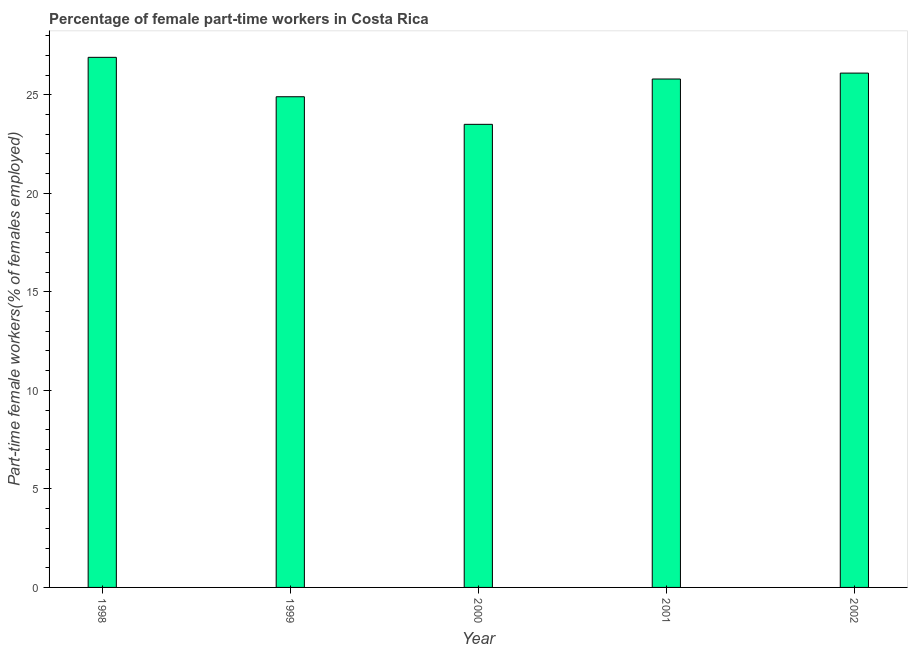Does the graph contain grids?
Give a very brief answer. No. What is the title of the graph?
Your answer should be very brief. Percentage of female part-time workers in Costa Rica. What is the label or title of the Y-axis?
Provide a short and direct response. Part-time female workers(% of females employed). Across all years, what is the maximum percentage of part-time female workers?
Your answer should be compact. 26.9. Across all years, what is the minimum percentage of part-time female workers?
Keep it short and to the point. 23.5. In which year was the percentage of part-time female workers minimum?
Offer a very short reply. 2000. What is the sum of the percentage of part-time female workers?
Keep it short and to the point. 127.2. What is the difference between the percentage of part-time female workers in 2000 and 2001?
Your answer should be very brief. -2.3. What is the average percentage of part-time female workers per year?
Make the answer very short. 25.44. What is the median percentage of part-time female workers?
Provide a succinct answer. 25.8. In how many years, is the percentage of part-time female workers greater than 10 %?
Provide a succinct answer. 5. What is the difference between the highest and the second highest percentage of part-time female workers?
Provide a short and direct response. 0.8. Is the sum of the percentage of part-time female workers in 2001 and 2002 greater than the maximum percentage of part-time female workers across all years?
Give a very brief answer. Yes. How many years are there in the graph?
Provide a short and direct response. 5. What is the difference between two consecutive major ticks on the Y-axis?
Provide a short and direct response. 5. Are the values on the major ticks of Y-axis written in scientific E-notation?
Keep it short and to the point. No. What is the Part-time female workers(% of females employed) of 1998?
Give a very brief answer. 26.9. What is the Part-time female workers(% of females employed) of 1999?
Make the answer very short. 24.9. What is the Part-time female workers(% of females employed) of 2001?
Offer a very short reply. 25.8. What is the Part-time female workers(% of females employed) in 2002?
Your answer should be compact. 26.1. What is the difference between the Part-time female workers(% of females employed) in 1998 and 2000?
Keep it short and to the point. 3.4. What is the difference between the Part-time female workers(% of females employed) in 1998 and 2002?
Provide a short and direct response. 0.8. What is the difference between the Part-time female workers(% of females employed) in 1999 and 2001?
Provide a short and direct response. -0.9. What is the difference between the Part-time female workers(% of females employed) in 1999 and 2002?
Provide a succinct answer. -1.2. What is the difference between the Part-time female workers(% of females employed) in 2000 and 2001?
Your response must be concise. -2.3. What is the difference between the Part-time female workers(% of females employed) in 2000 and 2002?
Your answer should be compact. -2.6. What is the difference between the Part-time female workers(% of females employed) in 2001 and 2002?
Keep it short and to the point. -0.3. What is the ratio of the Part-time female workers(% of females employed) in 1998 to that in 1999?
Your response must be concise. 1.08. What is the ratio of the Part-time female workers(% of females employed) in 1998 to that in 2000?
Your response must be concise. 1.15. What is the ratio of the Part-time female workers(% of females employed) in 1998 to that in 2001?
Provide a succinct answer. 1.04. What is the ratio of the Part-time female workers(% of females employed) in 1998 to that in 2002?
Offer a terse response. 1.03. What is the ratio of the Part-time female workers(% of females employed) in 1999 to that in 2000?
Provide a short and direct response. 1.06. What is the ratio of the Part-time female workers(% of females employed) in 1999 to that in 2001?
Keep it short and to the point. 0.96. What is the ratio of the Part-time female workers(% of females employed) in 1999 to that in 2002?
Make the answer very short. 0.95. What is the ratio of the Part-time female workers(% of females employed) in 2000 to that in 2001?
Offer a terse response. 0.91. What is the ratio of the Part-time female workers(% of females employed) in 2000 to that in 2002?
Offer a very short reply. 0.9. What is the ratio of the Part-time female workers(% of females employed) in 2001 to that in 2002?
Make the answer very short. 0.99. 